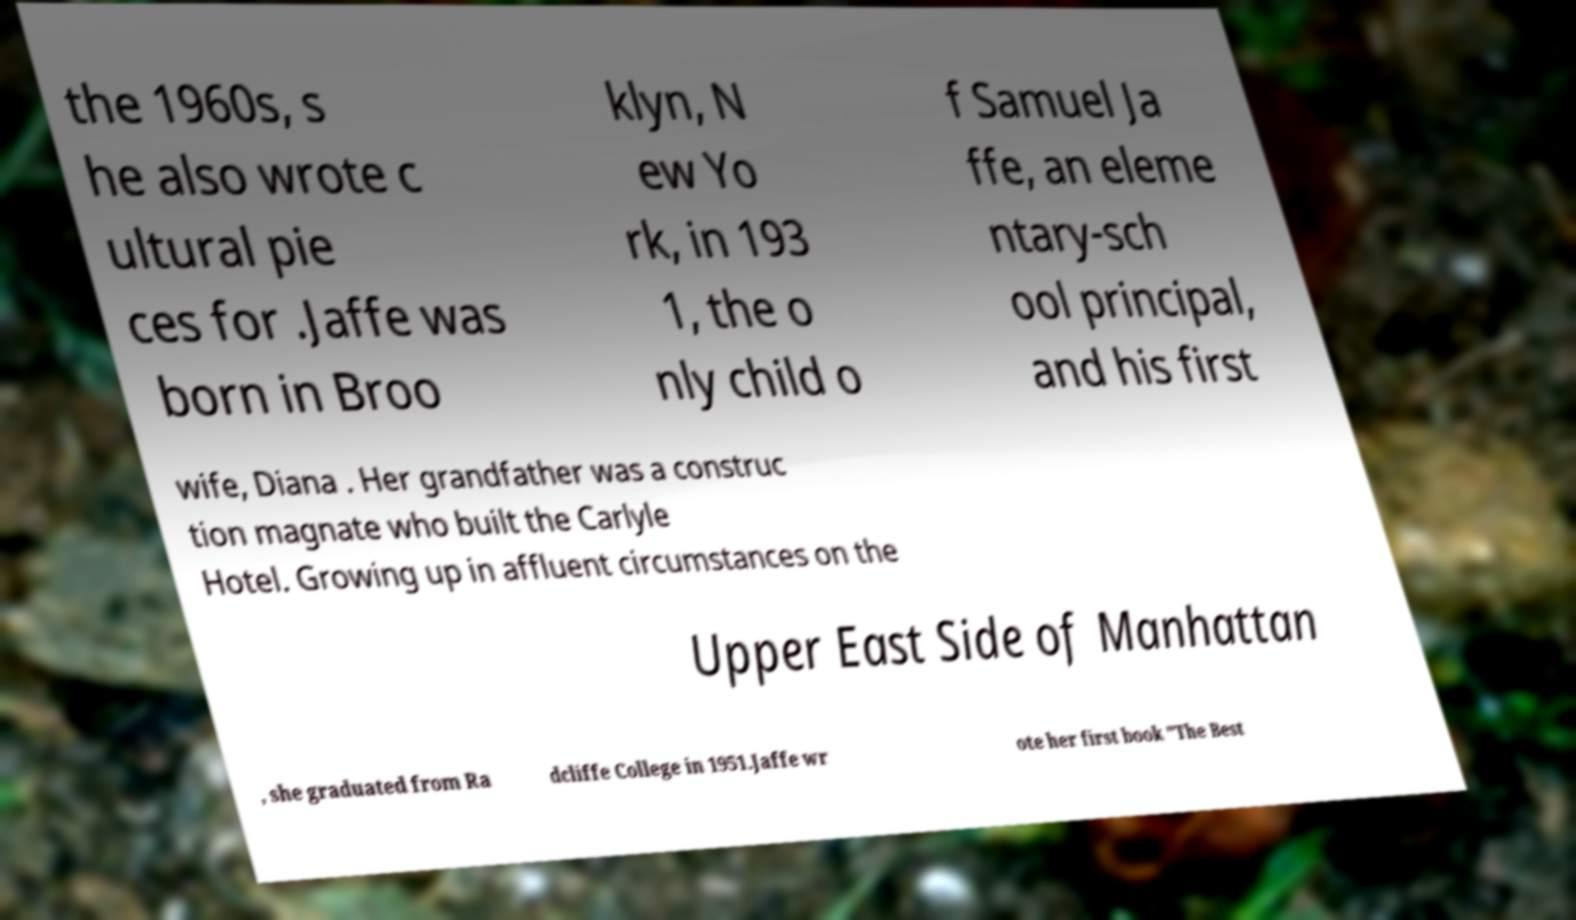Can you read and provide the text displayed in the image?This photo seems to have some interesting text. Can you extract and type it out for me? the 1960s, s he also wrote c ultural pie ces for .Jaffe was born in Broo klyn, N ew Yo rk, in 193 1, the o nly child o f Samuel Ja ffe, an eleme ntary-sch ool principal, and his first wife, Diana . Her grandfather was a construc tion magnate who built the Carlyle Hotel. Growing up in affluent circumstances on the Upper East Side of Manhattan , she graduated from Ra dcliffe College in 1951.Jaffe wr ote her first book "The Best 